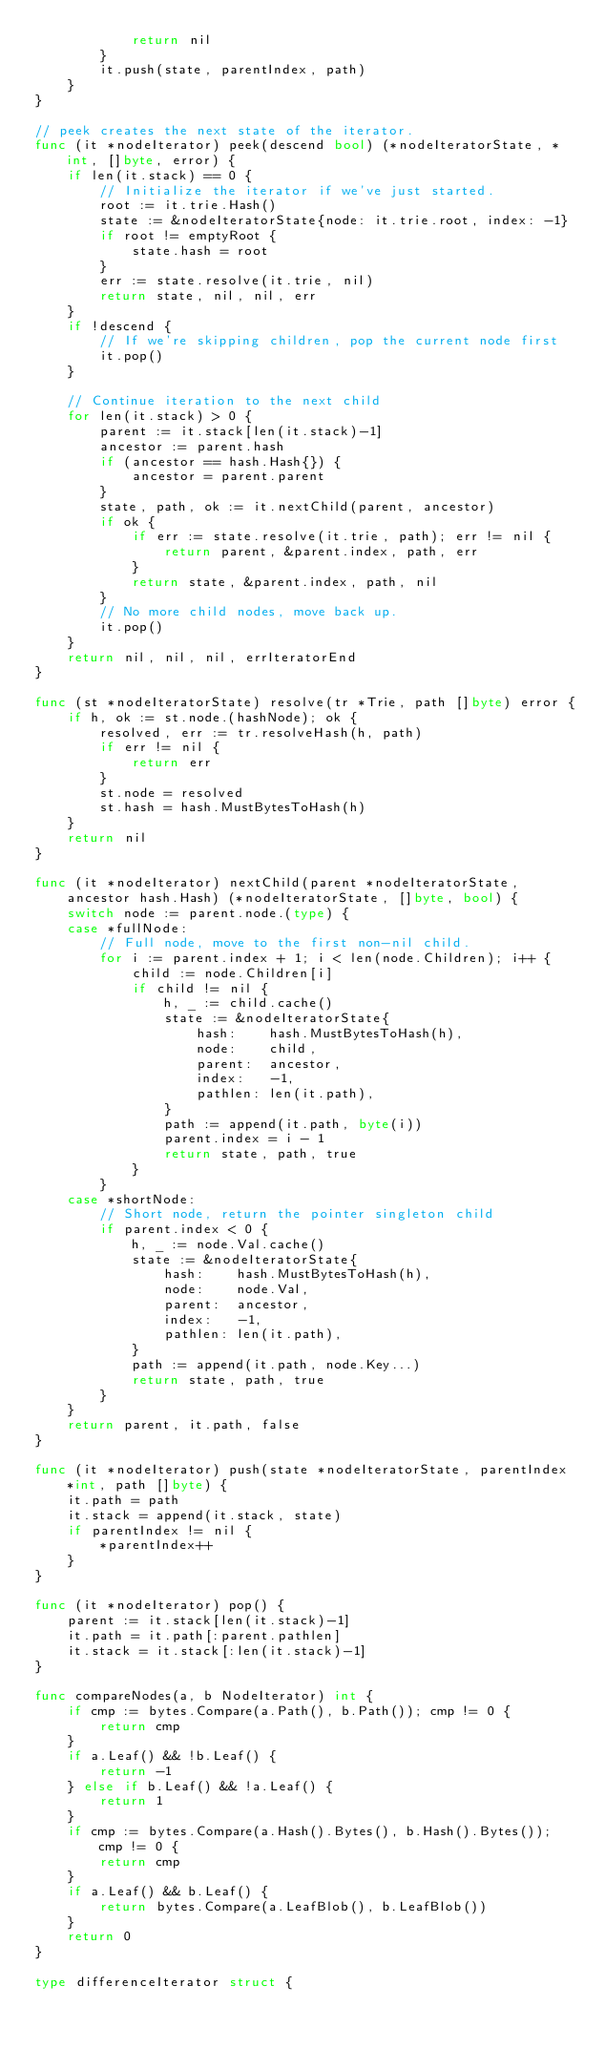Convert code to text. <code><loc_0><loc_0><loc_500><loc_500><_Go_>			return nil
		}
		it.push(state, parentIndex, path)
	}
}

// peek creates the next state of the iterator.
func (it *nodeIterator) peek(descend bool) (*nodeIteratorState, *int, []byte, error) {
	if len(it.stack) == 0 {
		// Initialize the iterator if we've just started.
		root := it.trie.Hash()
		state := &nodeIteratorState{node: it.trie.root, index: -1}
		if root != emptyRoot {
			state.hash = root
		}
		err := state.resolve(it.trie, nil)
		return state, nil, nil, err
	}
	if !descend {
		// If we're skipping children, pop the current node first
		it.pop()
	}

	// Continue iteration to the next child
	for len(it.stack) > 0 {
		parent := it.stack[len(it.stack)-1]
		ancestor := parent.hash
		if (ancestor == hash.Hash{}) {
			ancestor = parent.parent
		}
		state, path, ok := it.nextChild(parent, ancestor)
		if ok {
			if err := state.resolve(it.trie, path); err != nil {
				return parent, &parent.index, path, err
			}
			return state, &parent.index, path, nil
		}
		// No more child nodes, move back up.
		it.pop()
	}
	return nil, nil, nil, errIteratorEnd
}

func (st *nodeIteratorState) resolve(tr *Trie, path []byte) error {
	if h, ok := st.node.(hashNode); ok {
		resolved, err := tr.resolveHash(h, path)
		if err != nil {
			return err
		}
		st.node = resolved
		st.hash = hash.MustBytesToHash(h)
	}
	return nil
}

func (it *nodeIterator) nextChild(parent *nodeIteratorState, ancestor hash.Hash) (*nodeIteratorState, []byte, bool) {
	switch node := parent.node.(type) {
	case *fullNode:
		// Full node, move to the first non-nil child.
		for i := parent.index + 1; i < len(node.Children); i++ {
			child := node.Children[i]
			if child != nil {
				h, _ := child.cache()
				state := &nodeIteratorState{
					hash:    hash.MustBytesToHash(h),
					node:    child,
					parent:  ancestor,
					index:   -1,
					pathlen: len(it.path),
				}
				path := append(it.path, byte(i))
				parent.index = i - 1
				return state, path, true
			}
		}
	case *shortNode:
		// Short node, return the pointer singleton child
		if parent.index < 0 {
			h, _ := node.Val.cache()
			state := &nodeIteratorState{
				hash:    hash.MustBytesToHash(h),
				node:    node.Val,
				parent:  ancestor,
				index:   -1,
				pathlen: len(it.path),
			}
			path := append(it.path, node.Key...)
			return state, path, true
		}
	}
	return parent, it.path, false
}

func (it *nodeIterator) push(state *nodeIteratorState, parentIndex *int, path []byte) {
	it.path = path
	it.stack = append(it.stack, state)
	if parentIndex != nil {
		*parentIndex++
	}
}

func (it *nodeIterator) pop() {
	parent := it.stack[len(it.stack)-1]
	it.path = it.path[:parent.pathlen]
	it.stack = it.stack[:len(it.stack)-1]
}

func compareNodes(a, b NodeIterator) int {
	if cmp := bytes.Compare(a.Path(), b.Path()); cmp != 0 {
		return cmp
	}
	if a.Leaf() && !b.Leaf() {
		return -1
	} else if b.Leaf() && !a.Leaf() {
		return 1
	}
	if cmp := bytes.Compare(a.Hash().Bytes(), b.Hash().Bytes()); cmp != 0 {
		return cmp
	}
	if a.Leaf() && b.Leaf() {
		return bytes.Compare(a.LeafBlob(), b.LeafBlob())
	}
	return 0
}

type differenceIterator struct {</code> 